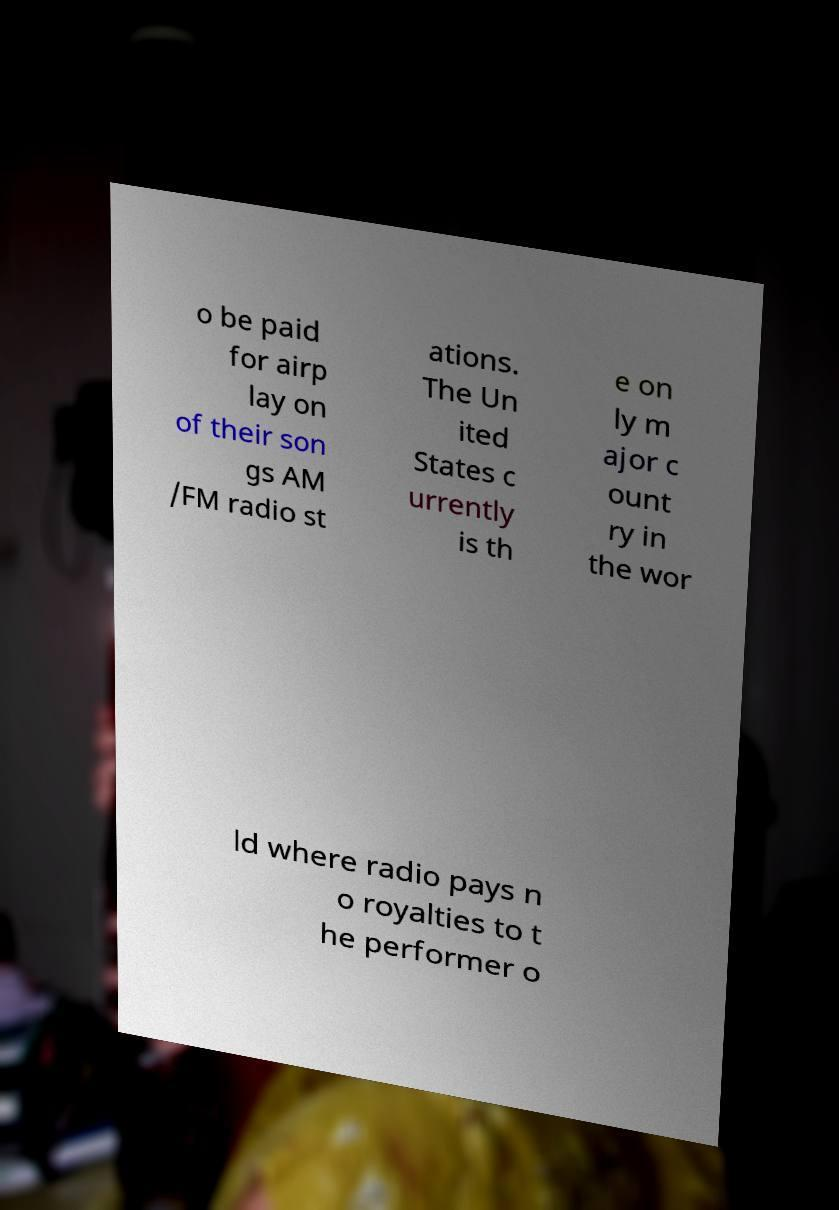What messages or text are displayed in this image? I need them in a readable, typed format. o be paid for airp lay on of their son gs AM /FM radio st ations. The Un ited States c urrently is th e on ly m ajor c ount ry in the wor ld where radio pays n o royalties to t he performer o 